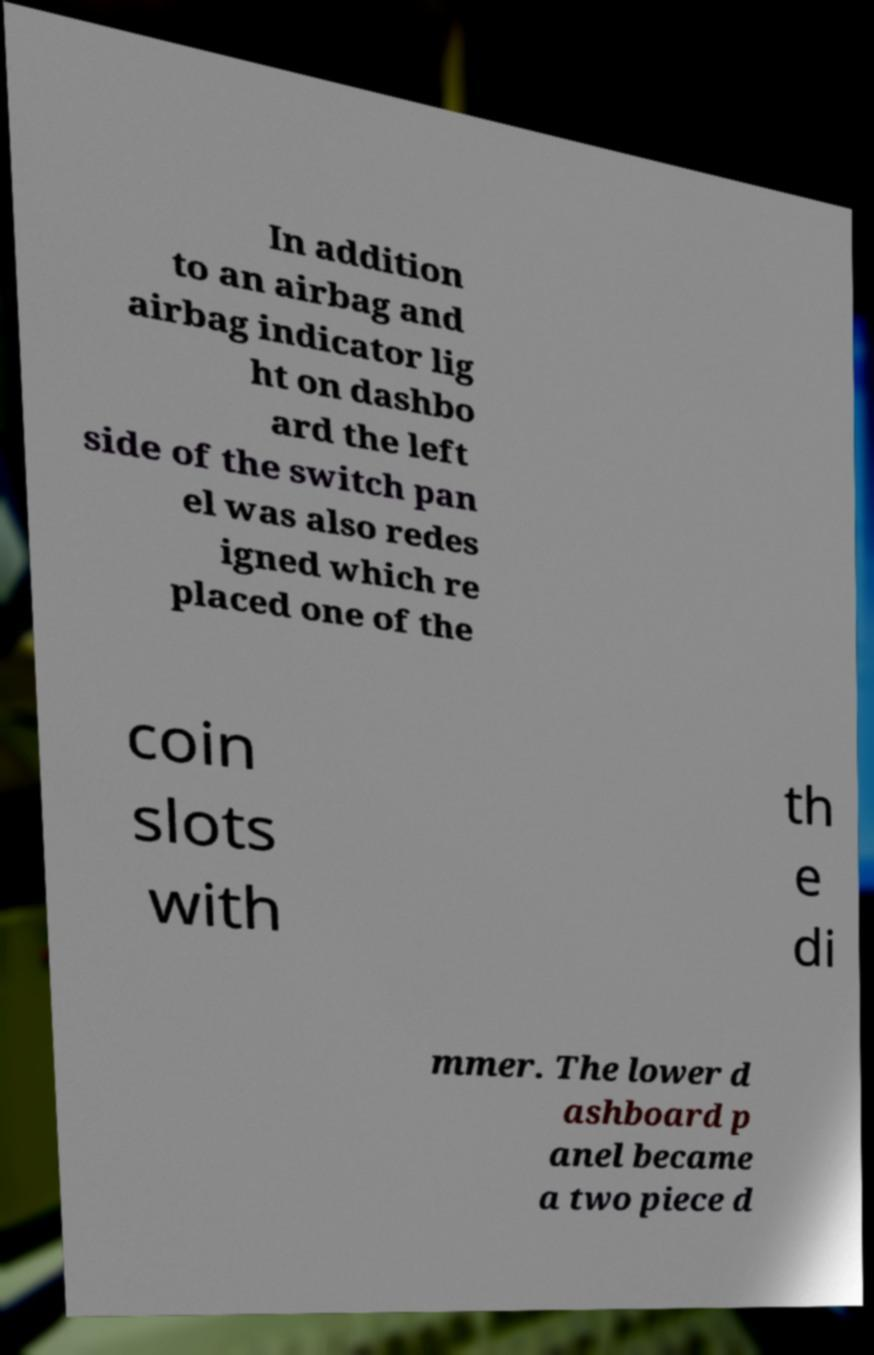Please identify and transcribe the text found in this image. In addition to an airbag and airbag indicator lig ht on dashbo ard the left side of the switch pan el was also redes igned which re placed one of the coin slots with th e di mmer. The lower d ashboard p anel became a two piece d 